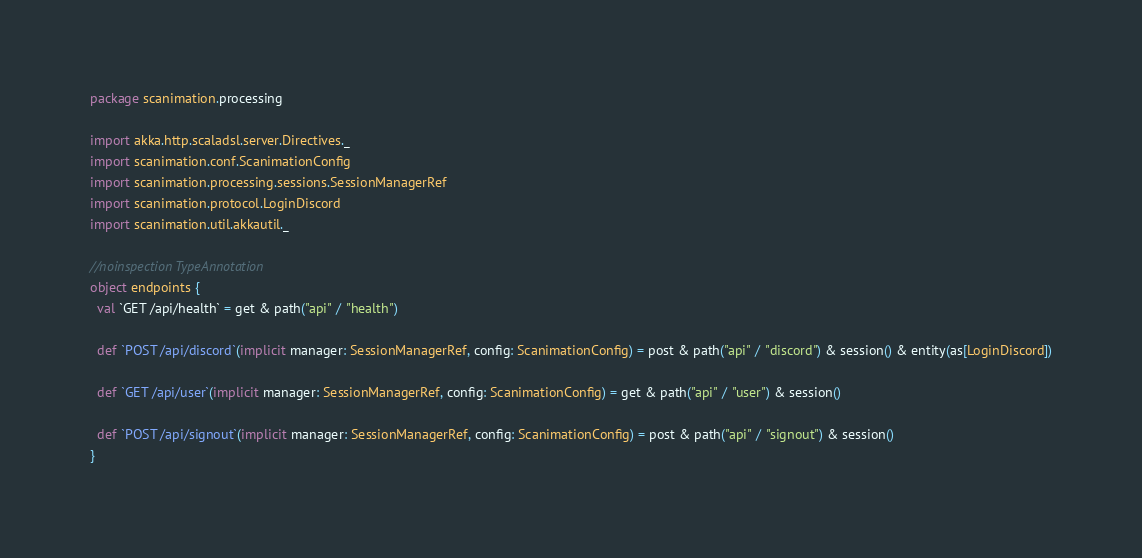Convert code to text. <code><loc_0><loc_0><loc_500><loc_500><_Scala_>package scanimation.processing

import akka.http.scaladsl.server.Directives._
import scanimation.conf.ScanimationConfig
import scanimation.processing.sessions.SessionManagerRef
import scanimation.protocol.LoginDiscord
import scanimation.util.akkautil._

//noinspection TypeAnnotation
object endpoints {
  val `GET /api/health` = get & path("api" / "health")

  def `POST /api/discord`(implicit manager: SessionManagerRef, config: ScanimationConfig) = post & path("api" / "discord") & session() & entity(as[LoginDiscord])

  def `GET /api/user`(implicit manager: SessionManagerRef, config: ScanimationConfig) = get & path("api" / "user") & session()

  def `POST /api/signout`(implicit manager: SessionManagerRef, config: ScanimationConfig) = post & path("api" / "signout") & session()
}</code> 